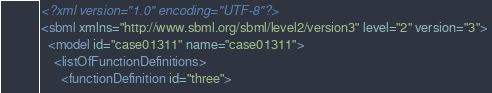<code> <loc_0><loc_0><loc_500><loc_500><_XML_><?xml version="1.0" encoding="UTF-8"?>
<sbml xmlns="http://www.sbml.org/sbml/level2/version3" level="2" version="3">
  <model id="case01311" name="case01311">
    <listOfFunctionDefinitions>
      <functionDefinition id="three"></code> 